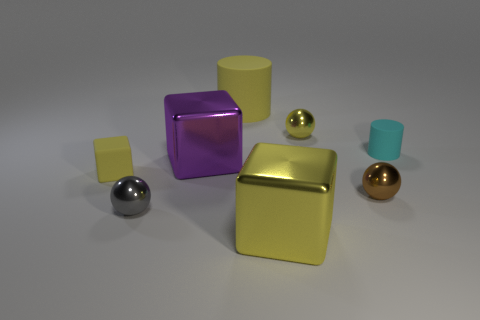Can you describe the colors of the various objects in the image? Certainly! In the image, we see objects in several colors: there's a gray and a gold sphere, a purple cube, a gold cube, a smaller matte yellow cube, and a smaller cyan cube. Which object appears to be the largest? The gold cube appears to be the largest object in the scene. 